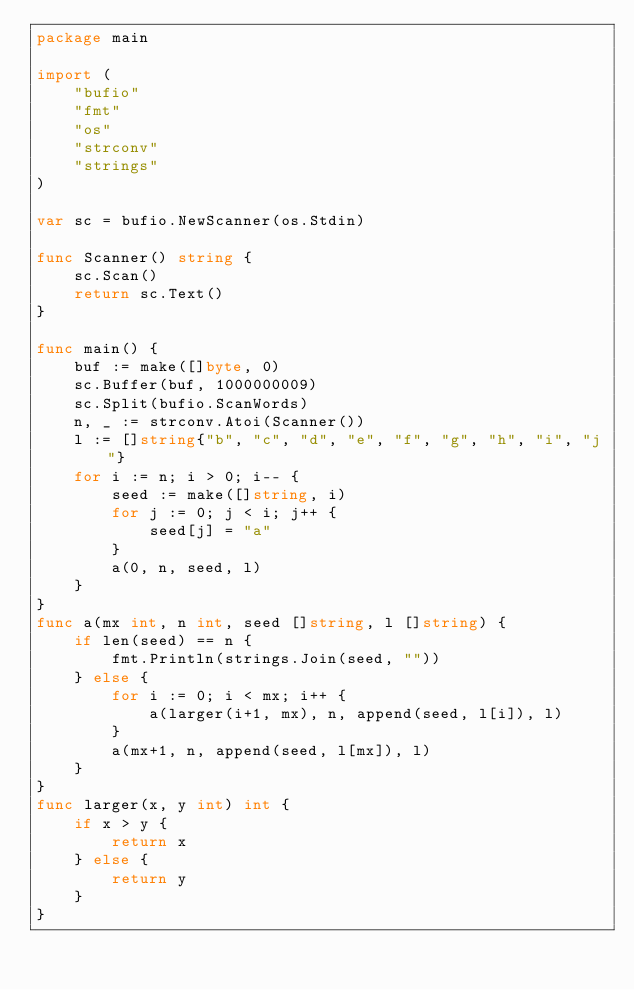<code> <loc_0><loc_0><loc_500><loc_500><_Go_>package main

import (
	"bufio"
	"fmt"
	"os"
	"strconv"
	"strings"
)

var sc = bufio.NewScanner(os.Stdin)

func Scanner() string {
	sc.Scan()
	return sc.Text()
}

func main() {
	buf := make([]byte, 0)
	sc.Buffer(buf, 1000000009)
	sc.Split(bufio.ScanWords)
	n, _ := strconv.Atoi(Scanner())
	l := []string{"b", "c", "d", "e", "f", "g", "h", "i", "j"}
	for i := n; i > 0; i-- {
		seed := make([]string, i)
		for j := 0; j < i; j++ {
			seed[j] = "a"
		}
		a(0, n, seed, l)
	}
}
func a(mx int, n int, seed []string, l []string) {
	if len(seed) == n {
		fmt.Println(strings.Join(seed, ""))
	} else {
		for i := 0; i < mx; i++ {
			a(larger(i+1, mx), n, append(seed, l[i]), l)
		}
		a(mx+1, n, append(seed, l[mx]), l)
	}
}
func larger(x, y int) int {
	if x > y {
		return x
	} else {
		return y
	}
}
</code> 